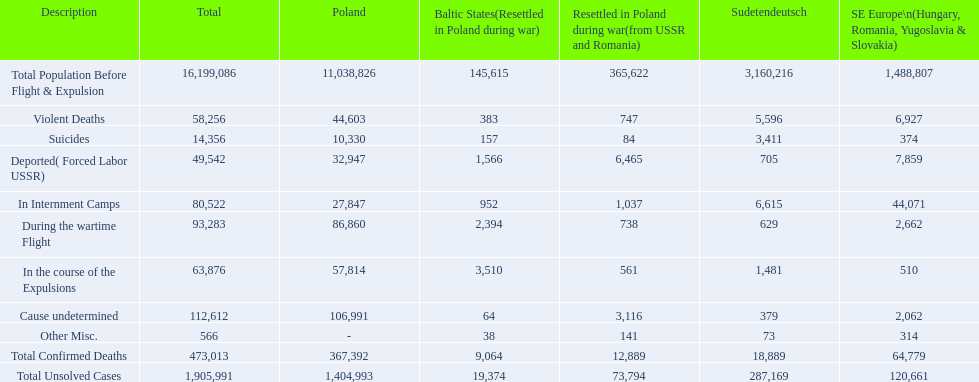What was the overall count of verified fatalities? 473,013. Of these, how many were brutal? 58,256. 